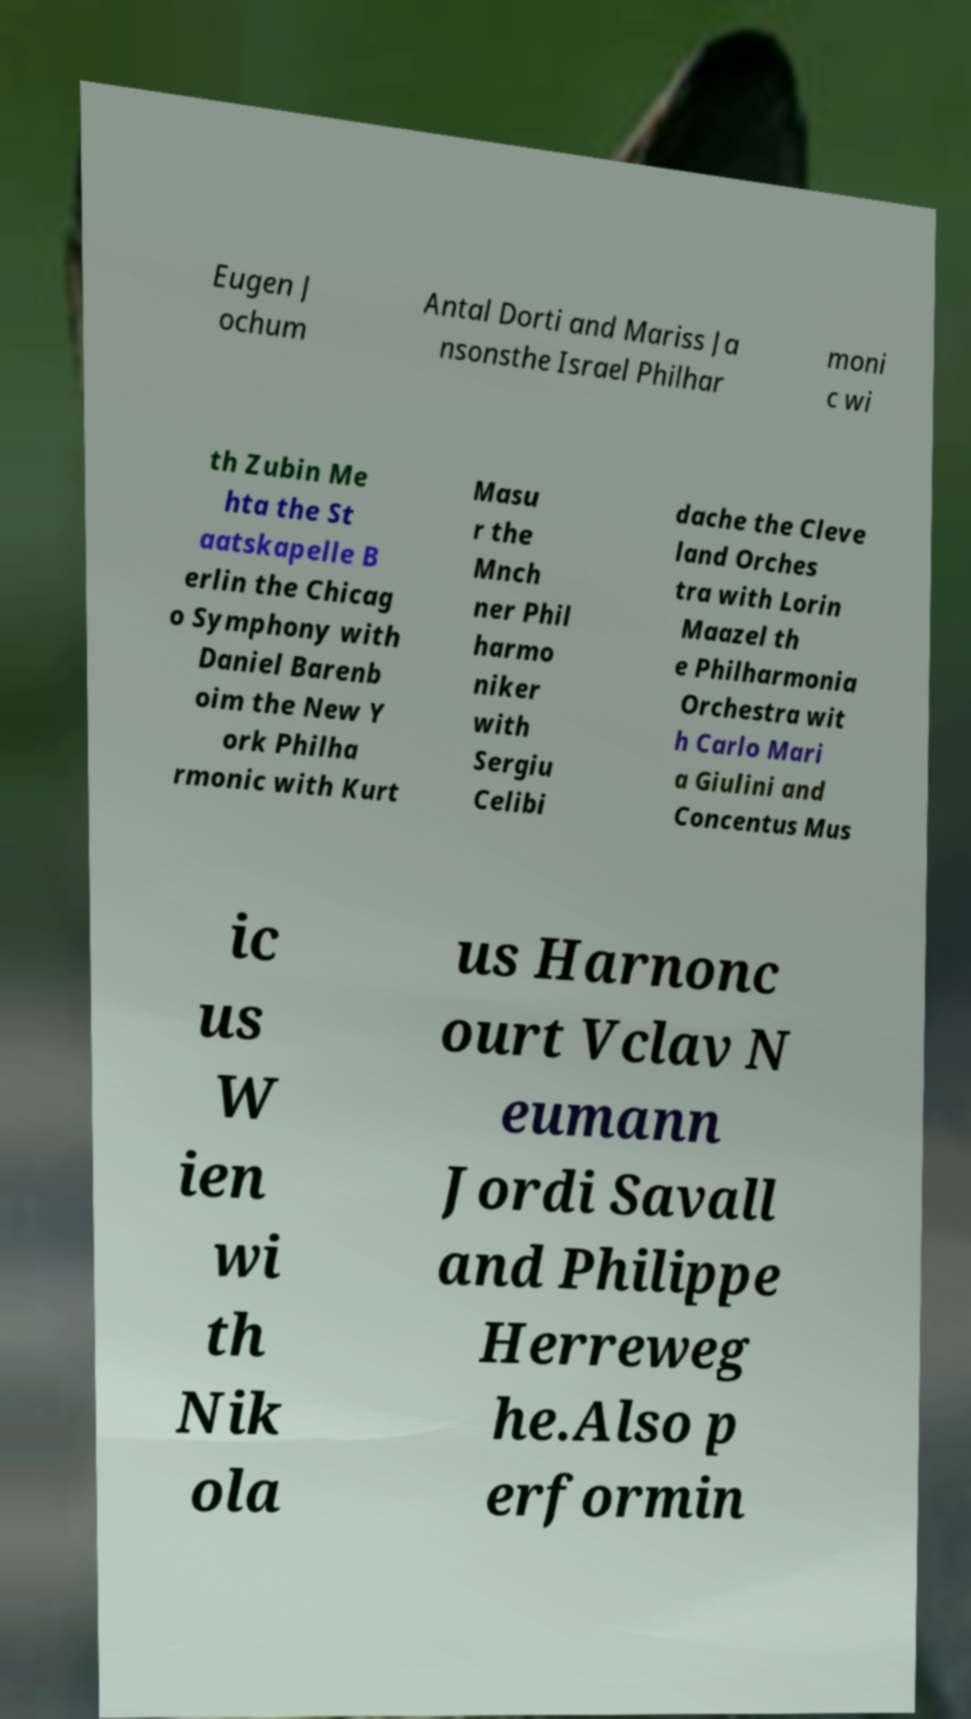Could you assist in decoding the text presented in this image and type it out clearly? Eugen J ochum Antal Dorti and Mariss Ja nsonsthe Israel Philhar moni c wi th Zubin Me hta the St aatskapelle B erlin the Chicag o Symphony with Daniel Barenb oim the New Y ork Philha rmonic with Kurt Masu r the Mnch ner Phil harmo niker with Sergiu Celibi dache the Cleve land Orches tra with Lorin Maazel th e Philharmonia Orchestra wit h Carlo Mari a Giulini and Concentus Mus ic us W ien wi th Nik ola us Harnonc ourt Vclav N eumann Jordi Savall and Philippe Herreweg he.Also p erformin 